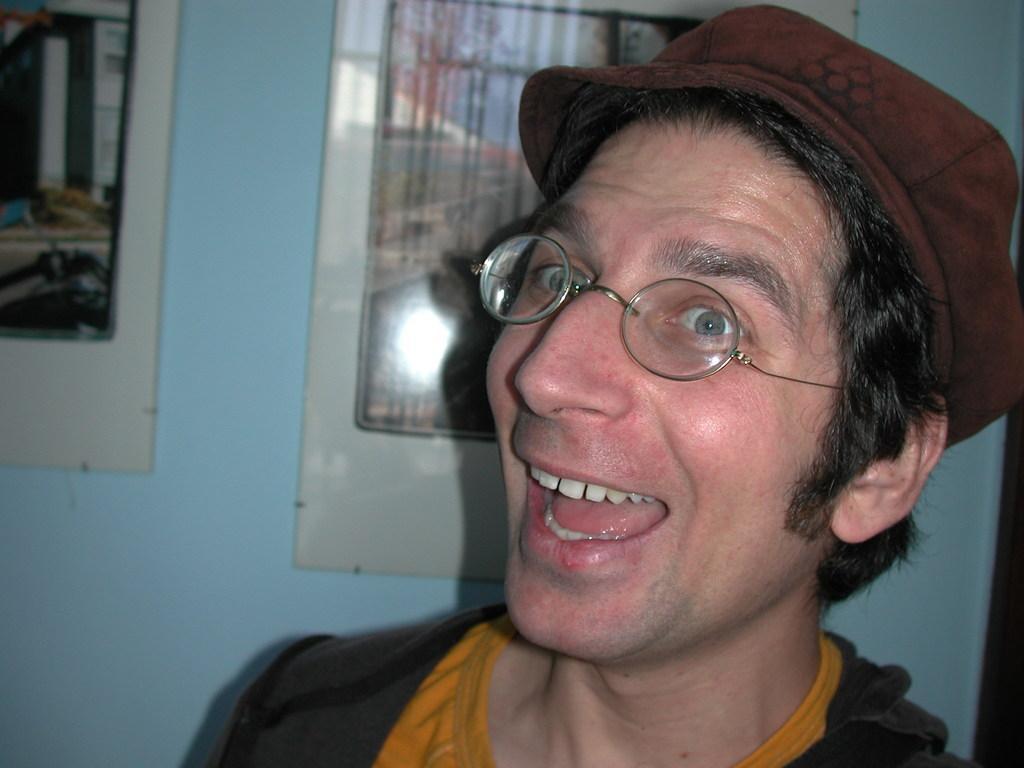Can you describe this image briefly? In the picture we can see a man opening his mouth and smiling and he is with black shirt and yellow T-shirt and behind him we can see a wall with two photo frames and some paintings on it and we can see a man wearing a cap which is brown in color. 